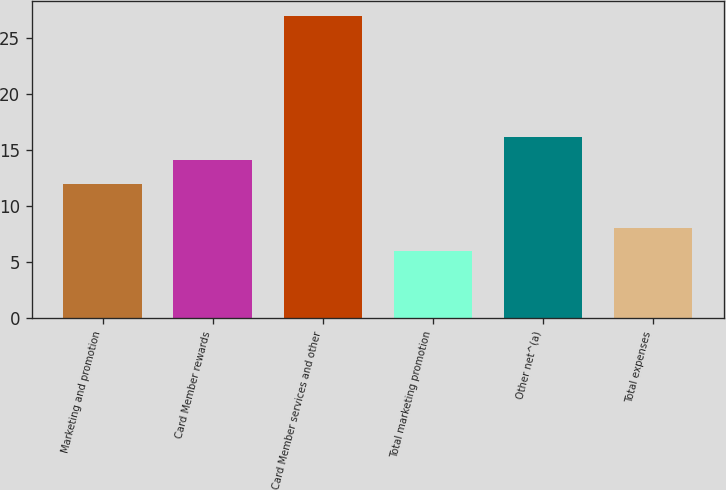<chart> <loc_0><loc_0><loc_500><loc_500><bar_chart><fcel>Marketing and promotion<fcel>Card Member rewards<fcel>Card Member services and other<fcel>Total marketing promotion<fcel>Other net^(a)<fcel>Total expenses<nl><fcel>12<fcel>14.1<fcel>27<fcel>6<fcel>16.2<fcel>8.1<nl></chart> 